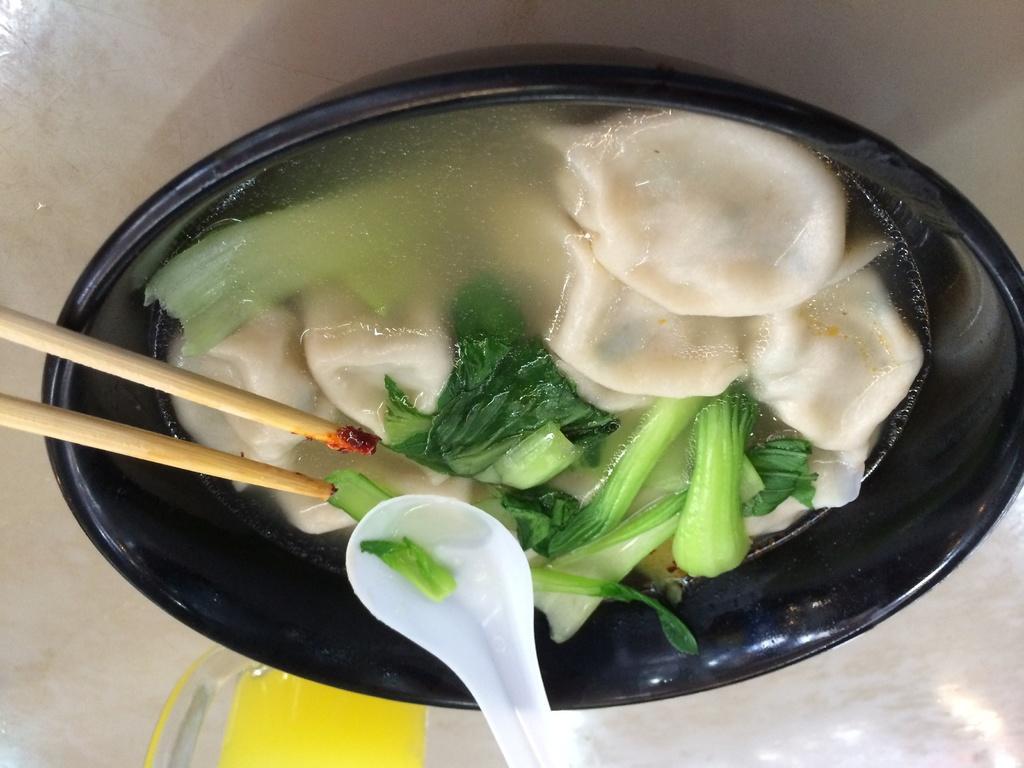How would you summarize this image in a sentence or two? In this picture there is bowl which is black in color inside it there is food. there is some green leafy vegetable in the food. There is spoon on the bowl and two chopsticks. 